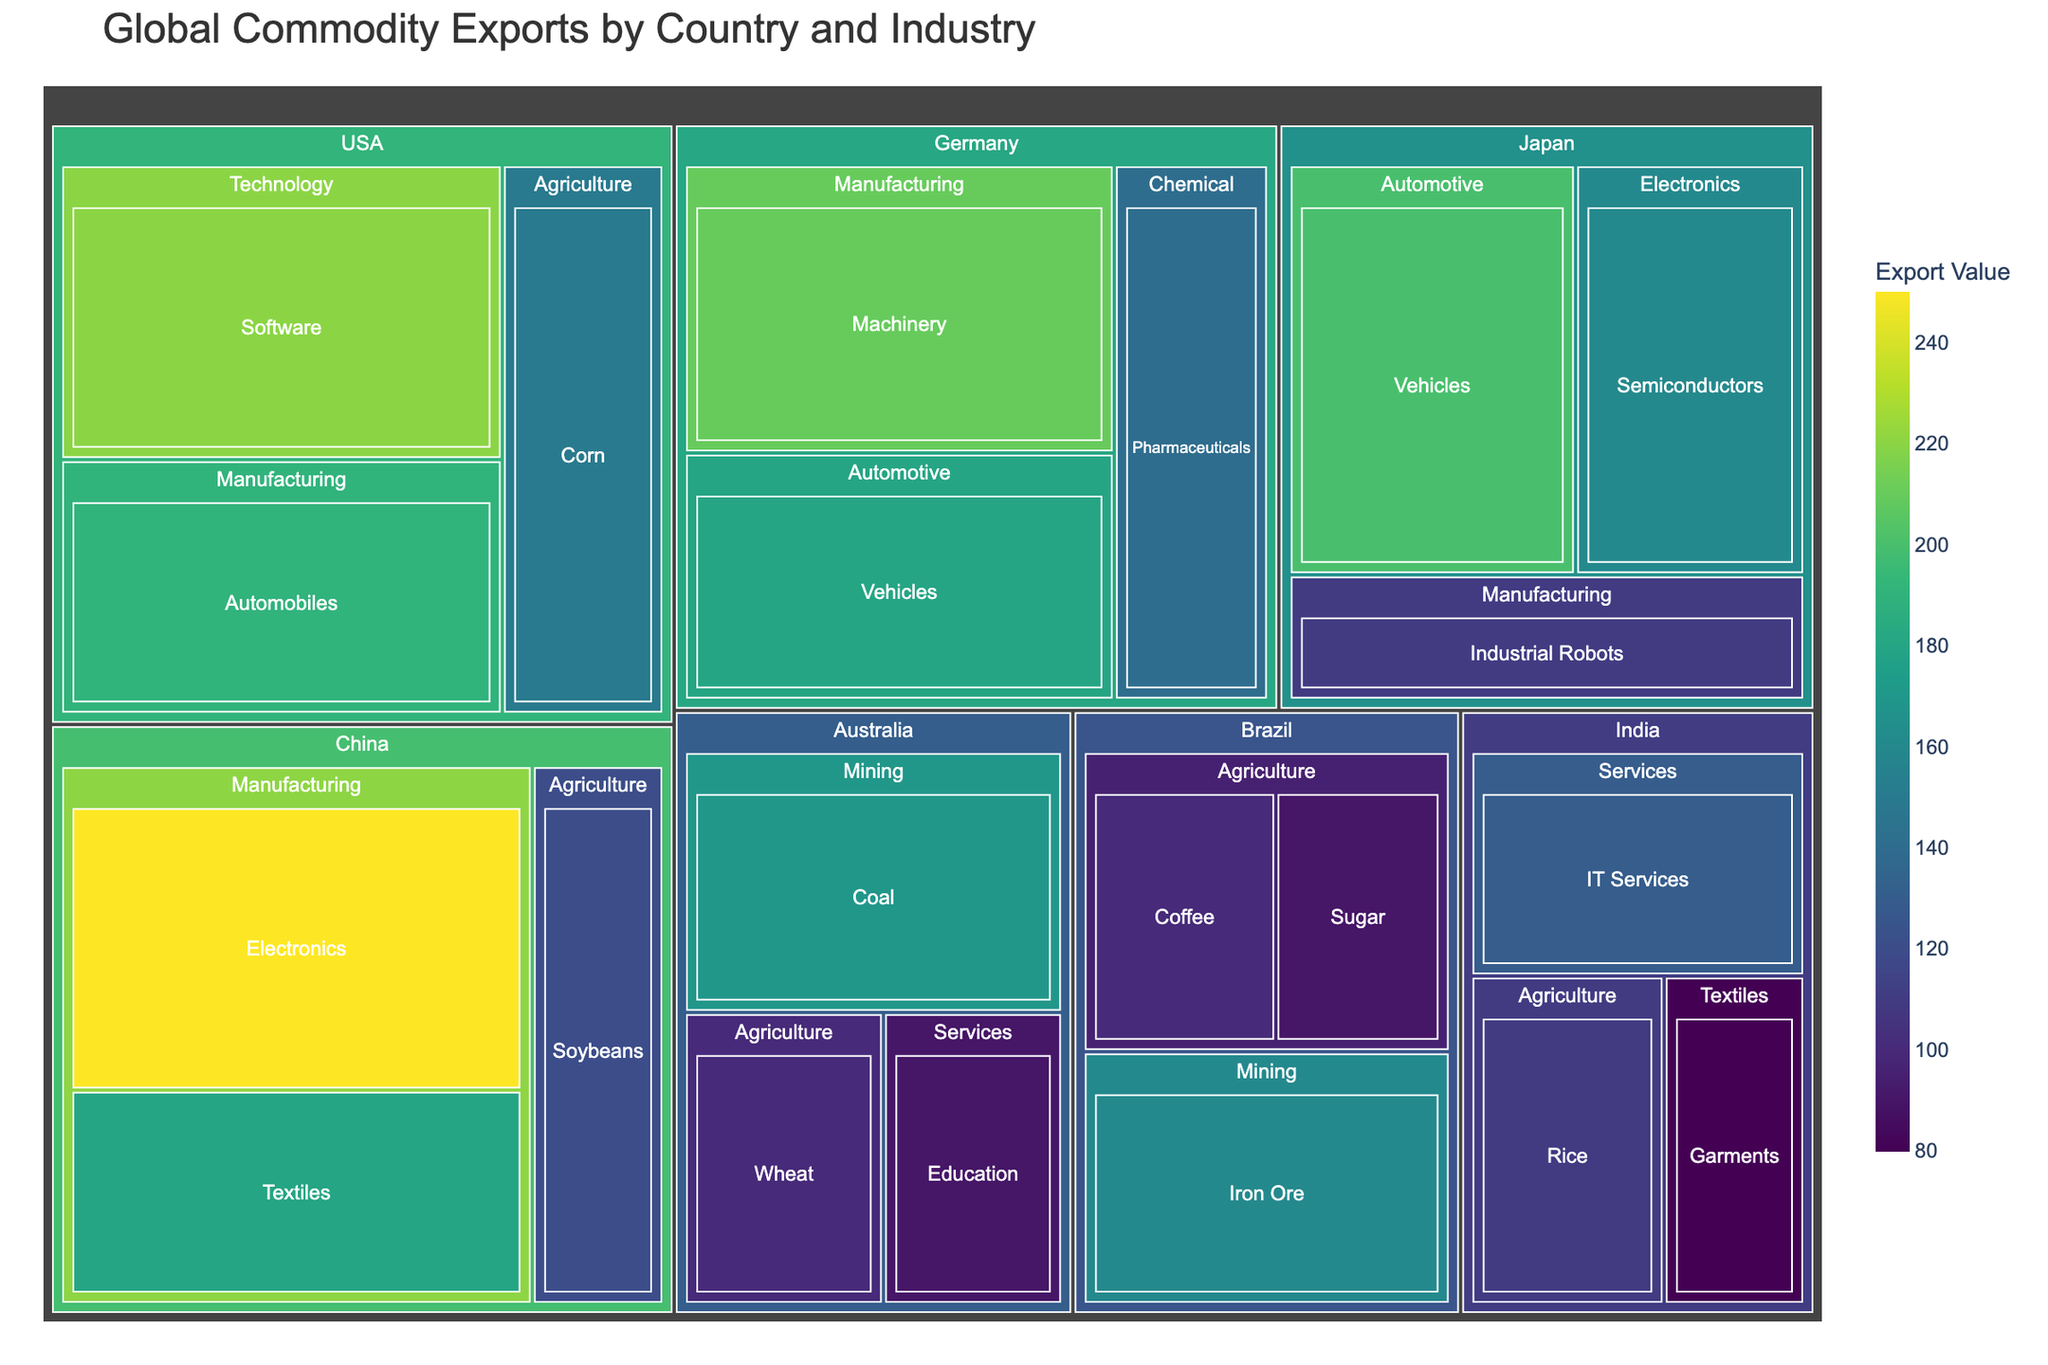What is the title of the treemap? The title is displayed prominently at the top of the figure. It helps in understanding the context and scope of the visual representation.
Answer: Global Commodity Exports by Country and Industry Which commodity has the highest export value in China? By looking at the size of the tiles under China, we can see that the largest tile represents Electronics, indicating it has the highest export value.
Answer: Electronics What is the combined export value of Brazil's Agriculture sector? Sum the values of commodities under Brazil's Agriculture sector: Coffee (100) + Sugar (90).
Answer: 190 million Which country has the most diverse set of industries? By counting the number of different industries represented under each country, USA and Germany each have 3 represented industries.
Answer: USA and Germany Which country has the highest export value in the Agriculture industry? Compare the sizes of the tiles within the Agriculture industry category across all countries. USA's Corn export has the highest value.
Answer: USA Compare the export values of USA's Software and India's IT Services. Compare the sizes or directly look at the values of the tiles for USA's Software (220) and India's IT Services (130).
Answer: USA's Software is greater What is the smallest export value in the entire treemap? Look for the smallest tile by size and value. The smallest commodity tile is India's Garments with a value of 80.
Answer: Garments (80 million) How does the value of Australia's Coal exports compare to Brazil's Iron Ore exports? Compare the values of the Coal commodity for Australia (170) and Iron Ore commodity for Brazil (160).
Answer: Australia's Coal exports are greater How many countries have exports in the Automotive industry? Identify all the tiles under the Automotive industry and count the distinct countries: Germany and Japan.
Answer: 2 countries What is the color scale used to represent the export values? The legend or color axis indicates the color scale used, which helps in understanding how different values are represented visually.
Answer: Viridis 